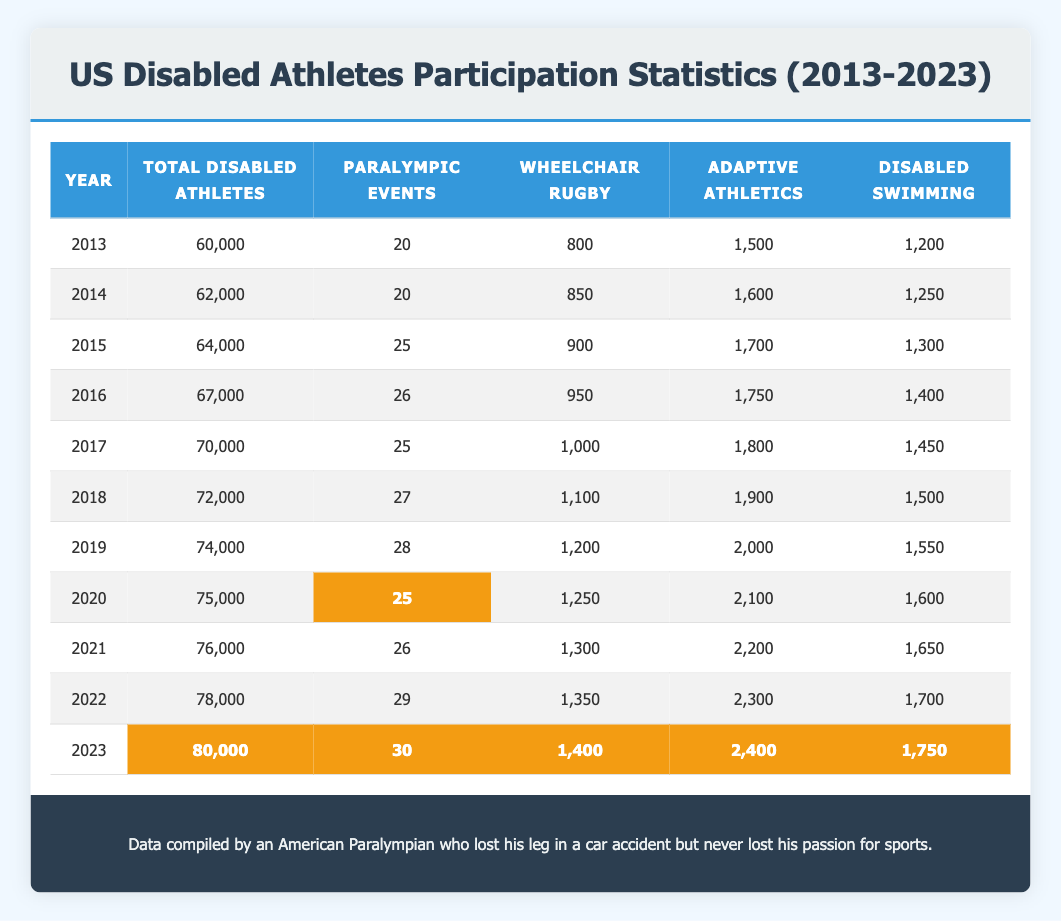What was the total number of disabled athletes in 2023? The table indicates that in 2023, the total number of disabled athletes is listed as 80,000.
Answer: 80,000 How many more disabled athletes participated in 2023 compared to 2013? In 2023, there were 80,000 disabled athletes and in 2013 there were 60,000. The difference is 80,000 - 60,000 = 20,000.
Answer: 20,000 Was the number of athletes in wheelchair rugby higher in 2022 than in 2021? In 2022, there were 1,350 athletes in wheelchair rugby, whereas in 2021, there were 1,300. Since 1,350 is greater than 1,300, the statement is true.
Answer: Yes What was the average number of Paralympic events across the years 2013 to 2023? The total number of Paralympic events from 2013 to 2023 is (20 + 20 + 25 + 26 + 25 + 27 + 28 + 25 + 26 + 29 + 30) =  25.5. There are 11 years, so the average is 295/11 ≈ 26.82, which can be simplified to approximately 27.
Answer: 27 Which year saw the highest participation in adaptive athletics, and what was the number? The highest participation in adaptive athletics occurred in 2023, with 2,400 athletes, as no other year has a higher number listed in the table.
Answer: 2023, 2,400 How many disabled athletes were there in 2020, and how does that compare to 2021? In 2020, there were 75,000 disabled athletes, and in 2021, there were 76,000. The comparison shows that there were 1,000 more athletes in 2021 than in 2020 (76,000 - 75,000 = 1,000).
Answer: 75,000; 1,000 more in 2021 What percentage of the total disabled athletes in 2023 were athletes in disabled swimming? In 2023, there were 80,000 disabled athletes and 1,750 athletes in disabled swimming. The percentage is (1,750 / 80,000) * 100 = 2.19%.
Answer: 2.19% Which sport had the greatest increase in participation from 2013 to 2023? The number of athletes in wheelchair rugby increased from 800 in 2013 to 1,400 in 2023, resulting in an increase of 600 athletes (1,400 - 800 = 600). Other sports show lower increases; hence wheelchair rugby had the greatest increase.
Answer: Wheelchair rugby How many Paralympic events took place in 2016? The table shows that there were 26 Paralympic events in 2016.
Answer: 26 What was the total number of athletes in adaptive athletics in 2017 and 2023 combined? From the table, there were 1,800 athletes in adaptive athletics in 2017 and 2,400 in 2023. Adding these gives 1,800 + 2,400 = 4,200.
Answer: 4,200 